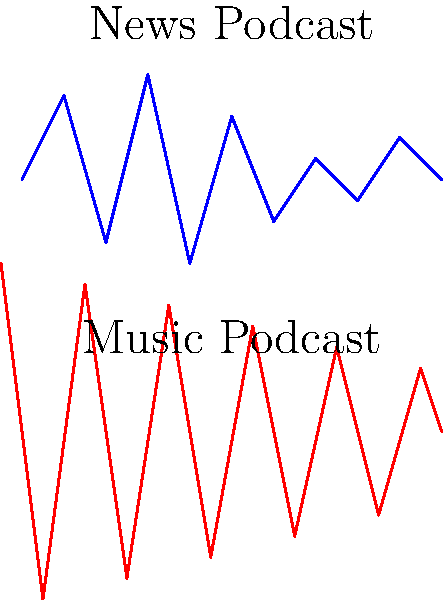As a podcast enthusiast, you're interested in understanding how machine learning algorithms classify podcast genres based on audio waveforms. Given the waveform images above, which characteristic would likely be most useful for an ML model to distinguish between news and music podcasts? To answer this question, let's analyze the waveforms step-by-step:

1. Observe the news podcast waveform (blue):
   - It has relatively consistent amplitude throughout
   - The peaks and troughs are less extreme
   - There's a more uniform pattern, reflecting speech

2. Examine the music podcast waveform (red):
   - It shows greater variation in amplitude
   - The peaks and troughs are more extreme
   - There's a less uniform pattern, reflecting musical elements

3. Compare the two waveforms:
   - The most striking difference is the amplitude range
   - Music has higher peaks and lower troughs
   - News maintains a more consistent, moderate amplitude

4. Consider what these differences represent:
   - News podcasts typically feature consistent speech
   - Music podcasts have varying instruments, beats, and vocals

5. Determine the most distinguishing feature:
   - The amplitude range (difference between highest and lowest points) is the most notable difference
   - This characteristic directly relates to the dynamic range of the audio

Therefore, the amplitude range or dynamic range would likely be the most useful characteristic for an ML model to distinguish between news and music podcasts based on these waveform images.
Answer: Amplitude range (dynamic range) 